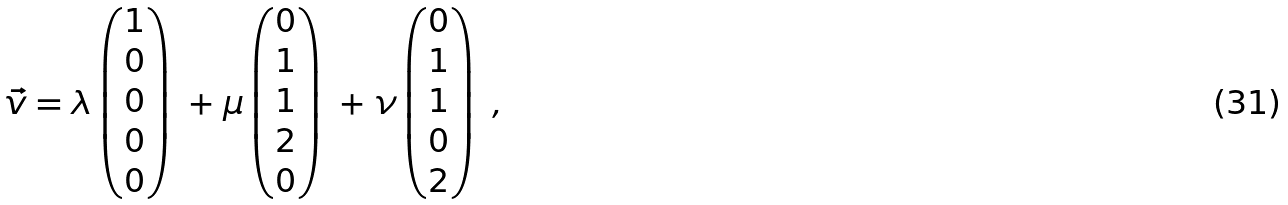Convert formula to latex. <formula><loc_0><loc_0><loc_500><loc_500>\vec { v } = \lambda \begin{pmatrix} 1 \\ 0 \\ 0 \\ 0 \\ 0 \end{pmatrix} \ + \mu \begin{pmatrix} 0 \\ 1 \\ 1 \\ 2 \\ 0 \end{pmatrix} \ + \nu \begin{pmatrix} 0 \\ 1 \\ 1 \\ 0 \\ 2 \end{pmatrix} \ ,</formula> 